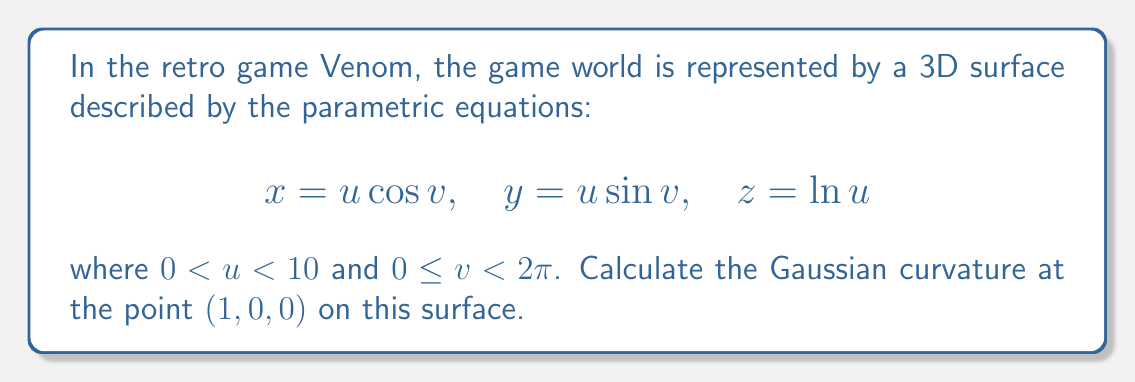Provide a solution to this math problem. To find the Gaussian curvature, we need to calculate the first and second fundamental forms, then use them to compute the curvature.

Step 1: Calculate the partial derivatives
$$\mathbf{r}_u = (\cos v, \sin v, \frac{1}{u})$$
$$\mathbf{r}_v = (-u \sin v, u \cos v, 0)$$
$$\mathbf{r}_{uu} = (0, 0, -\frac{1}{u^2})$$
$$\mathbf{r}_{uv} = (-\sin v, \cos v, 0)$$
$$\mathbf{r}_{vv} = (-u \cos v, -u \sin v, 0)$$

Step 2: Calculate the coefficients of the first fundamental form
$$E = \mathbf{r}_u \cdot \mathbf{r}_u = \cos^2 v + \sin^2 v + \frac{1}{u^2} = 1 + \frac{1}{u^2}$$
$$F = \mathbf{r}_u \cdot \mathbf{r}_v = 0$$
$$G = \mathbf{r}_v \cdot \mathbf{r}_v = u^2$$

Step 3: Calculate the unit normal vector
$$\mathbf{N} = \frac{\mathbf{r}_u \times \mathbf{r}_v}{|\mathbf{r}_u \times \mathbf{r}_v|} = \frac{(-u \cos v, -u \sin v, -u)}{\sqrt{u^2(1+u^2)}}$$

Step 4: Calculate the coefficients of the second fundamental form
$$L = \mathbf{r}_{uu} \cdot \mathbf{N} = \frac{u}{\sqrt{u^2(1+u^2)}}$$
$$M = \mathbf{r}_{uv} \cdot \mathbf{N} = 0$$
$$N = \mathbf{r}_{vv} \cdot \mathbf{N} = \frac{u^2}{\sqrt{u^2(1+u^2)}}$$

Step 5: Calculate the Gaussian curvature
$$K = \frac{LN - M^2}{EG - F^2} = \frac{(\frac{u}{\sqrt{u^2(1+u^2)}})(\frac{u^2}{\sqrt{u^2(1+u^2)}}) - 0^2}{(1 + \frac{1}{u^2})(u^2) - 0^2}$$

Step 6: Simplify and evaluate at the point (1, 0, 0)
At this point, $u = 1$ and $v = 0$. Substituting these values:

$$K = \frac{\frac{1}{\sqrt{2}} \cdot \frac{1}{\sqrt{2}}}{2} = \frac{1}{4}$$

Therefore, the Gaussian curvature at the point (1, 0, 0) is 1/4.
Answer: $\frac{1}{4}$ 